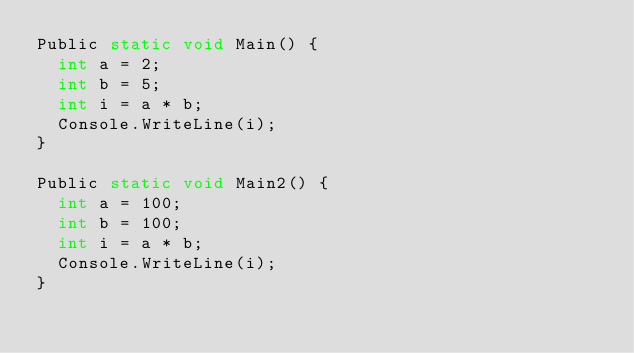<code> <loc_0><loc_0><loc_500><loc_500><_C#_>Public static void Main() {
  int a = 2;
  int b = 5;
  int i = a * b;
  Console.WriteLine(i);
} 
 
Public static void Main2() {
  int a = 100;
  int b = 100;
  int i = a * b;
  Console.WriteLine(i);
} </code> 